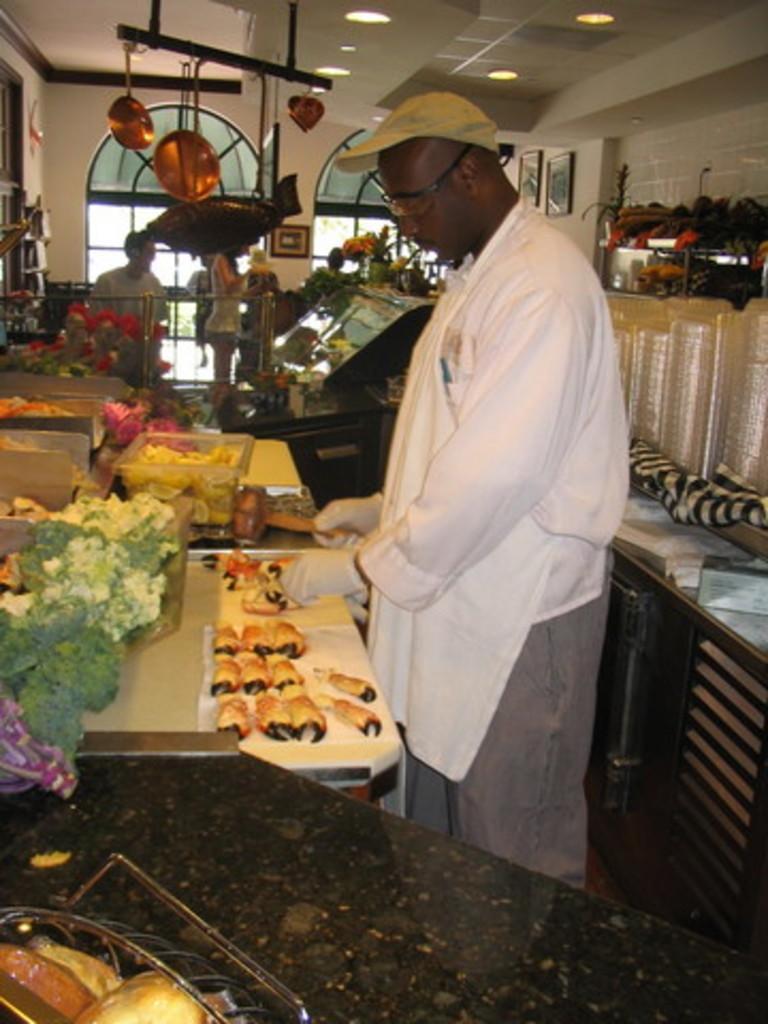Can you describe this image briefly? There is one man standing and wearing a white color shirt as we can see in the middle of this image. We can see food items and tables are present on the left side of this image and we can see people and a wall in the background. There is a table and some fruits are present on the right side of this image. 